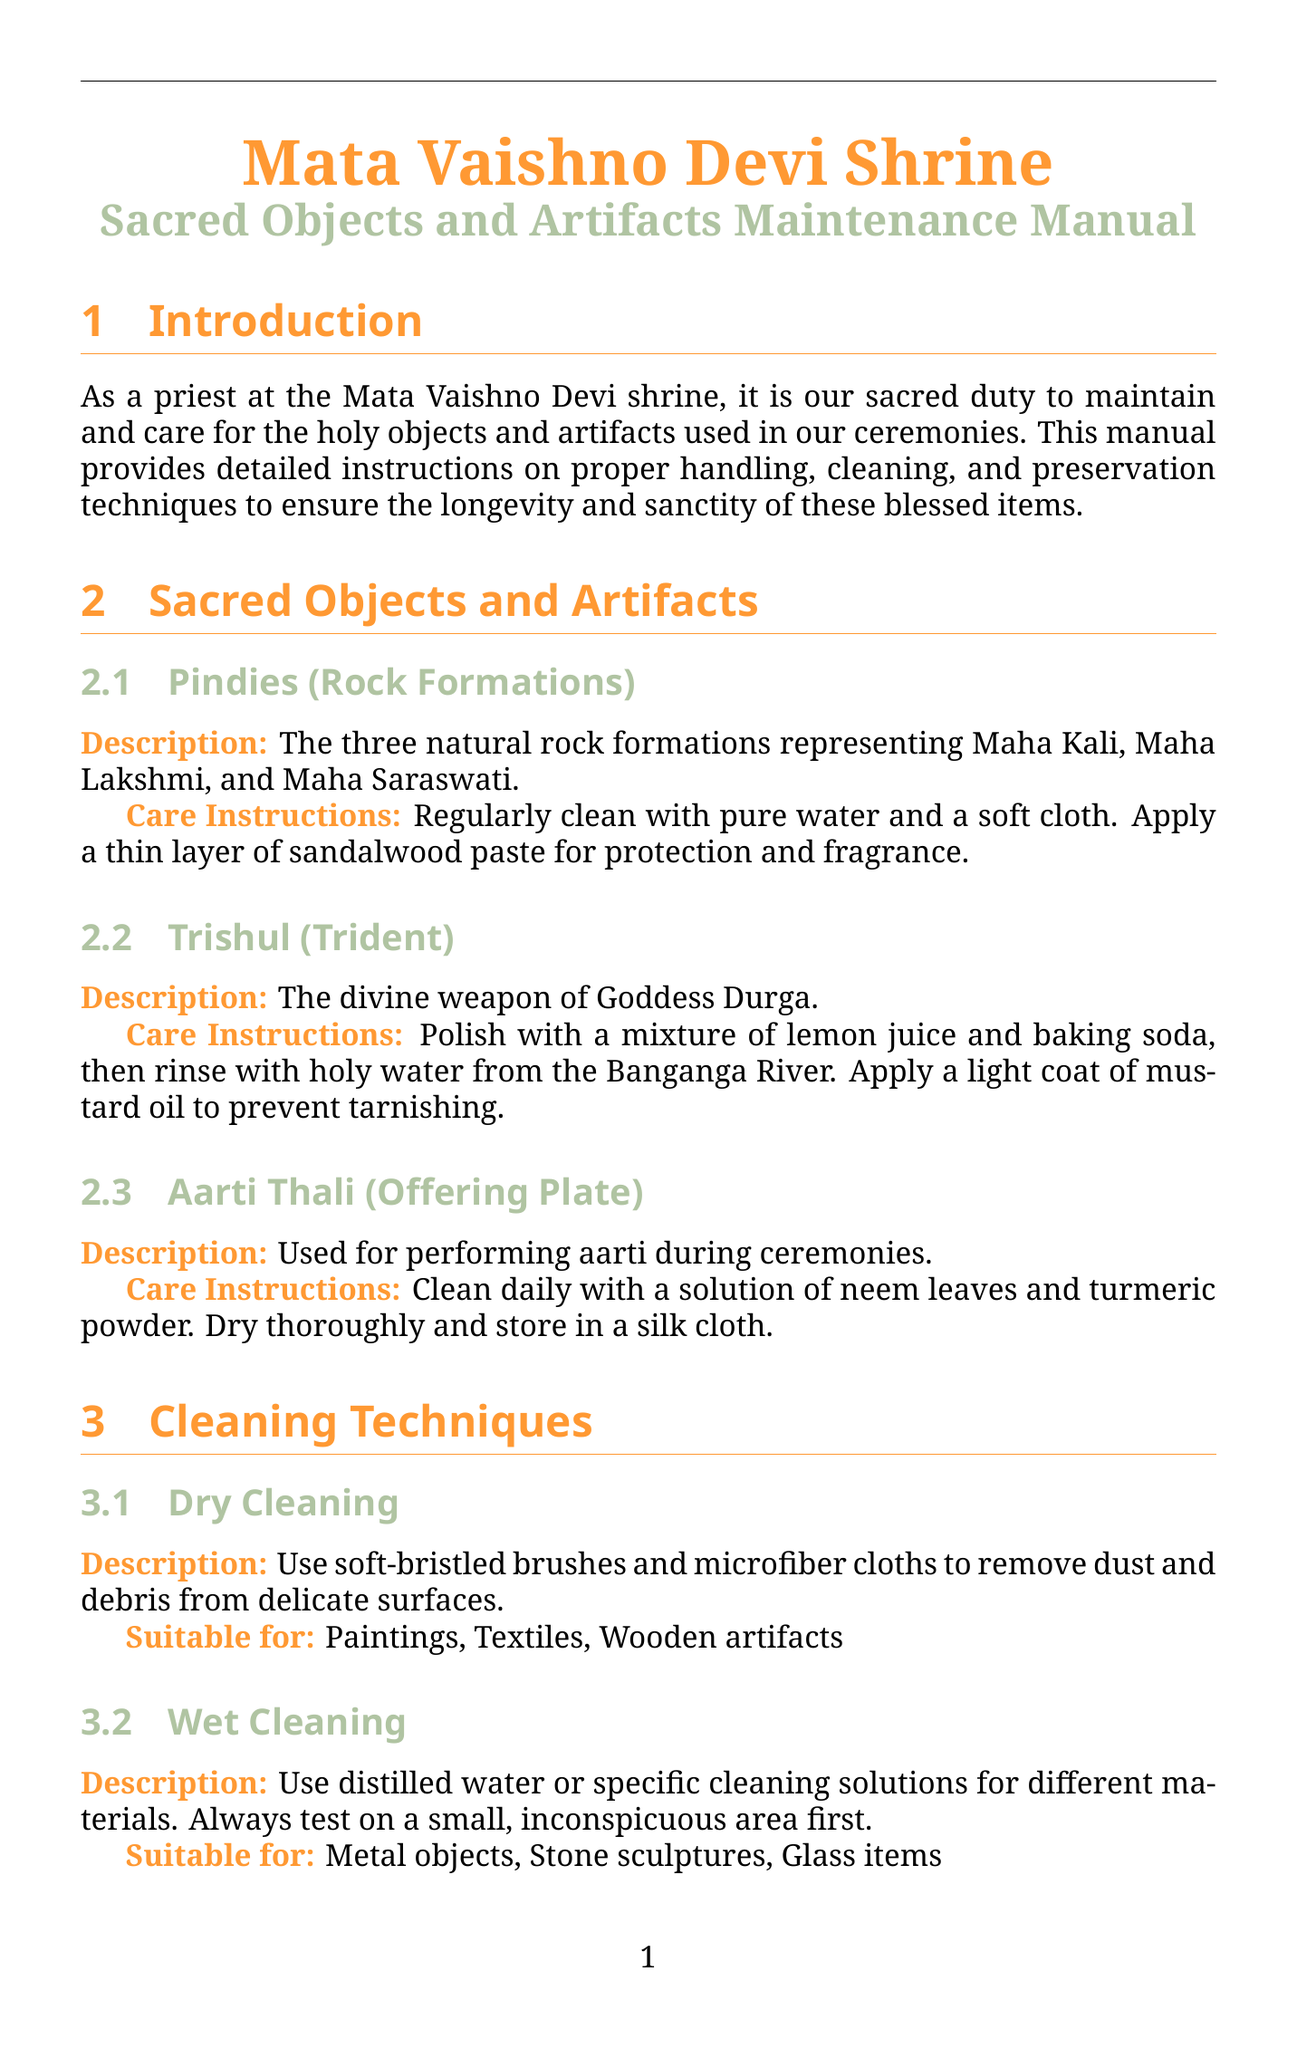what are the three rock formations called? The document describes the Pindies as representing Maha Kali, Maha Lakshmi, and Maha Saraswati.
Answer: Pindies what is used for cleaning the Aarti Thali? The care instructions specify that the Aarti Thali should be cleaned with a solution of neem leaves and turmeric powder.
Answer: Neem leaves and turmeric powder what is the optimal temperature for climate control? The preservation technique mentions maintaining an optimal temperature of 18-22°C in storage areas.
Answer: 18-22°C how often should a detailed inspection of all artifacts be conducted? The periodic maintenance schedule states that a detailed inspection of all artifacts should be conducted monthly.
Answer: Monthly what should be done immediately after water damage occurs? The emergency procedure recommends removing artifacts from the affected area immediately after water damage.
Answer: Remove artifacts immediately what natural fumigants are mentioned for protecting artifacts? The cleaning techniques section mentions using neem leaves and camphor as natural fumigants.
Answer: Neem leaves and camphor how often should professional conservation assessments be arranged? The periodic maintenance schedule specifies that professional conservation assessments should be arranged annually.
Answer: Annually what type of clothing should be avoided while handling artifacts? The handling guidelines indicate that loose clothing or jewelry should be avoided when handling artifacts.
Answer: Loose clothing or jewelry what is recommended to prevent tarnishing of the Trishul? The care instructions for the Trishul suggest applying a light coat of mustard oil to prevent tarnishing.
Answer: Mustard oil 